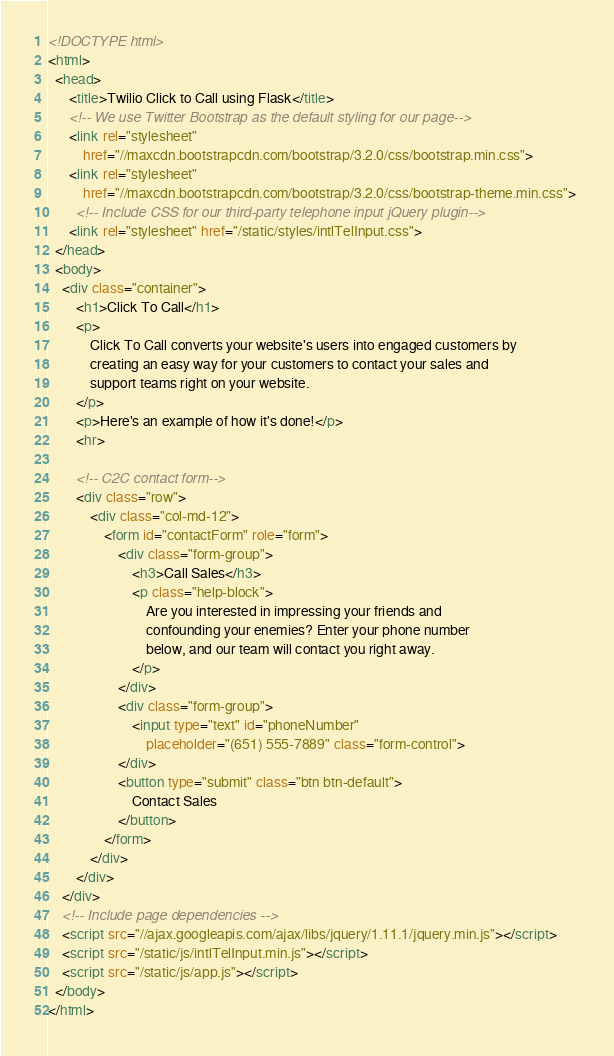<code> <loc_0><loc_0><loc_500><loc_500><_HTML_><!DOCTYPE html>
<html>
  <head>
      <title>Twilio Click to Call using Flask</title>
      <!-- We use Twitter Bootstrap as the default styling for our page-->
      <link rel="stylesheet" 
          href="//maxcdn.bootstrapcdn.com/bootstrap/3.2.0/css/bootstrap.min.css">
      <link rel="stylesheet" 
          href="//maxcdn.bootstrapcdn.com/bootstrap/3.2.0/css/bootstrap-theme.min.css"> 
        <!-- Include CSS for our third-party telephone input jQuery plugin-->
      <link rel="stylesheet" href="/static/styles/intlTelInput.css">
  </head>
  <body>
    <div class="container">
        <h1>Click To Call</h1>
        <p>
            Click To Call converts your website's users into engaged customers by 
            creating an easy way for your customers to contact your sales and 
            support teams right on your website.
        </p>
        <p>Here's an example of how it's done!</p>
        <hr>

        <!-- C2C contact form-->
        <div class="row">
            <div class="col-md-12">
                <form id="contactForm" role="form">
                    <div class="form-group">
                        <h3>Call Sales</h3>
                        <p class="help-block">
                            Are you interested in impressing your friends and 
                            confounding your enemies? Enter your phone number 
                            below, and our team will contact you right away.
                        </p>
                    </div>
                    <div class="form-group">
                        <input type="text" id="phoneNumber" 
                            placeholder="(651) 555-7889" class="form-control">
                    </div>
                    <button type="submit" class="btn btn-default">
                        Contact Sales
                    </button>
                </form>
            </div>
        </div>
    </div>
    <!-- Include page dependencies -->
    <script src="//ajax.googleapis.com/ajax/libs/jquery/1.11.1/jquery.min.js"></script>
    <script src="/static/js/intlTelInput.min.js"></script>
    <script src="/static/js/app.js"></script>
  </body>
</html>
</code> 